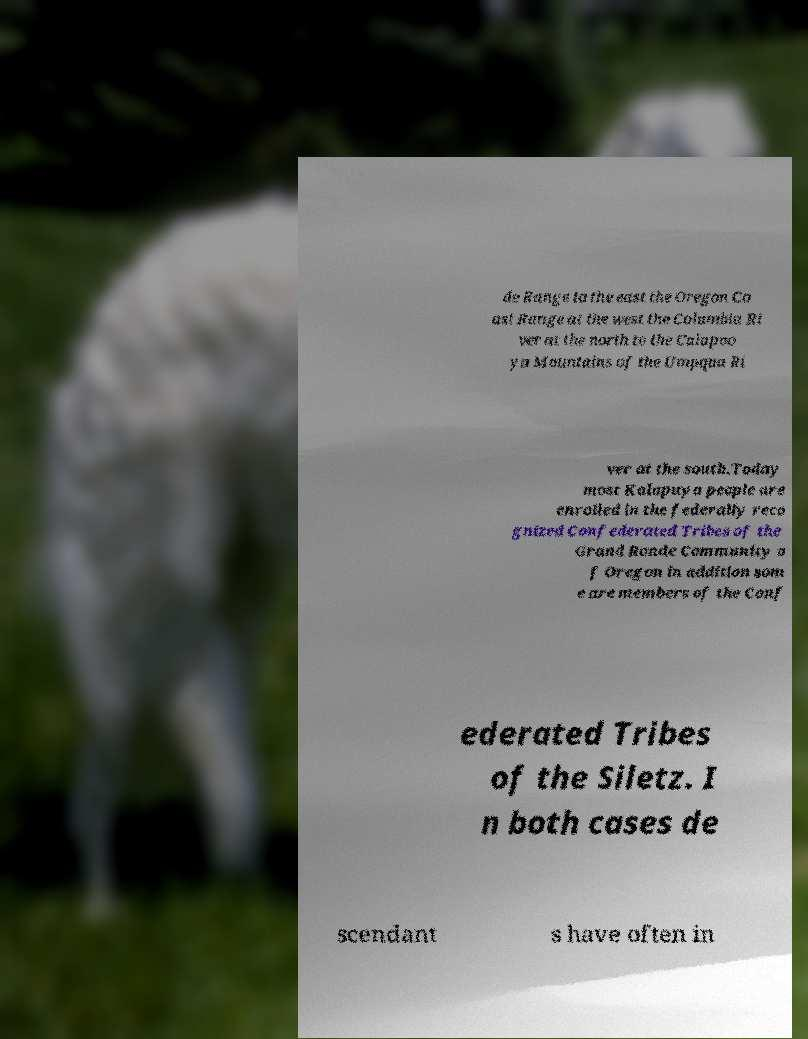What messages or text are displayed in this image? I need them in a readable, typed format. de Range to the east the Oregon Co ast Range at the west the Columbia Ri ver at the north to the Calapoo ya Mountains of the Umpqua Ri ver at the south.Today most Kalapuya people are enrolled in the federally reco gnized Confederated Tribes of the Grand Ronde Community o f Oregon in addition som e are members of the Conf ederated Tribes of the Siletz. I n both cases de scendant s have often in 